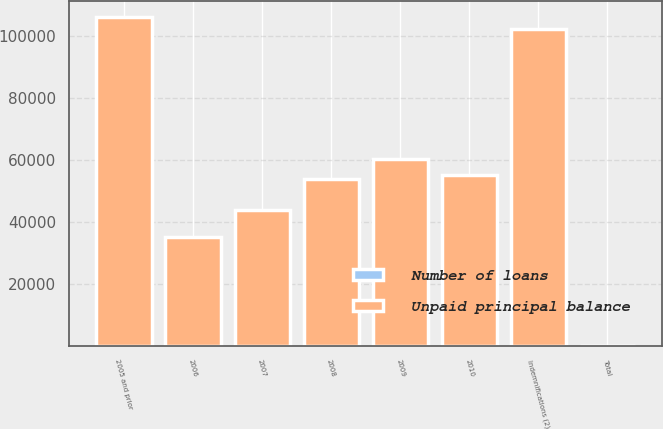Convert chart to OTSL. <chart><loc_0><loc_0><loc_500><loc_500><stacked_bar_chart><ecel><fcel>2005 and prior<fcel>2006<fcel>2007<fcel>2008<fcel>2009<fcel>2010<fcel>Indemnifications (2)<fcel>Total<nl><fcel>Number of loans<fcel>1<fcel>0.2<fcel>0.2<fcel>0.3<fcel>0.3<fcel>0.3<fcel>0.9<fcel>3.2<nl><fcel>Unpaid principal balance<fcel>105931<fcel>34969<fcel>43744<fcel>53759<fcel>60293<fcel>54936<fcel>102142<fcel>3.2<nl></chart> 